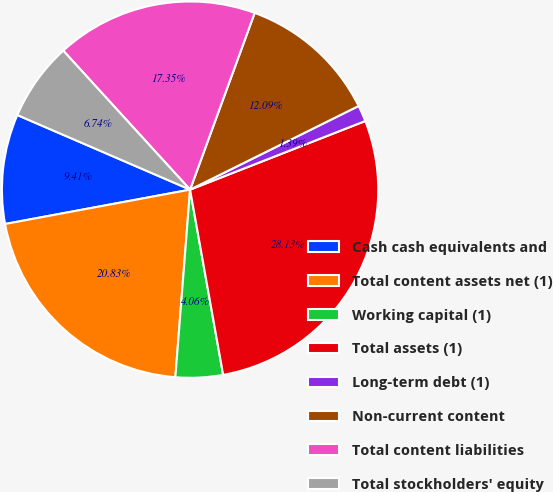<chart> <loc_0><loc_0><loc_500><loc_500><pie_chart><fcel>Cash cash equivalents and<fcel>Total content assets net (1)<fcel>Working capital (1)<fcel>Total assets (1)<fcel>Long-term debt (1)<fcel>Non-current content<fcel>Total content liabilities<fcel>Total stockholders' equity<nl><fcel>9.41%<fcel>20.83%<fcel>4.06%<fcel>28.13%<fcel>1.39%<fcel>12.09%<fcel>17.35%<fcel>6.74%<nl></chart> 